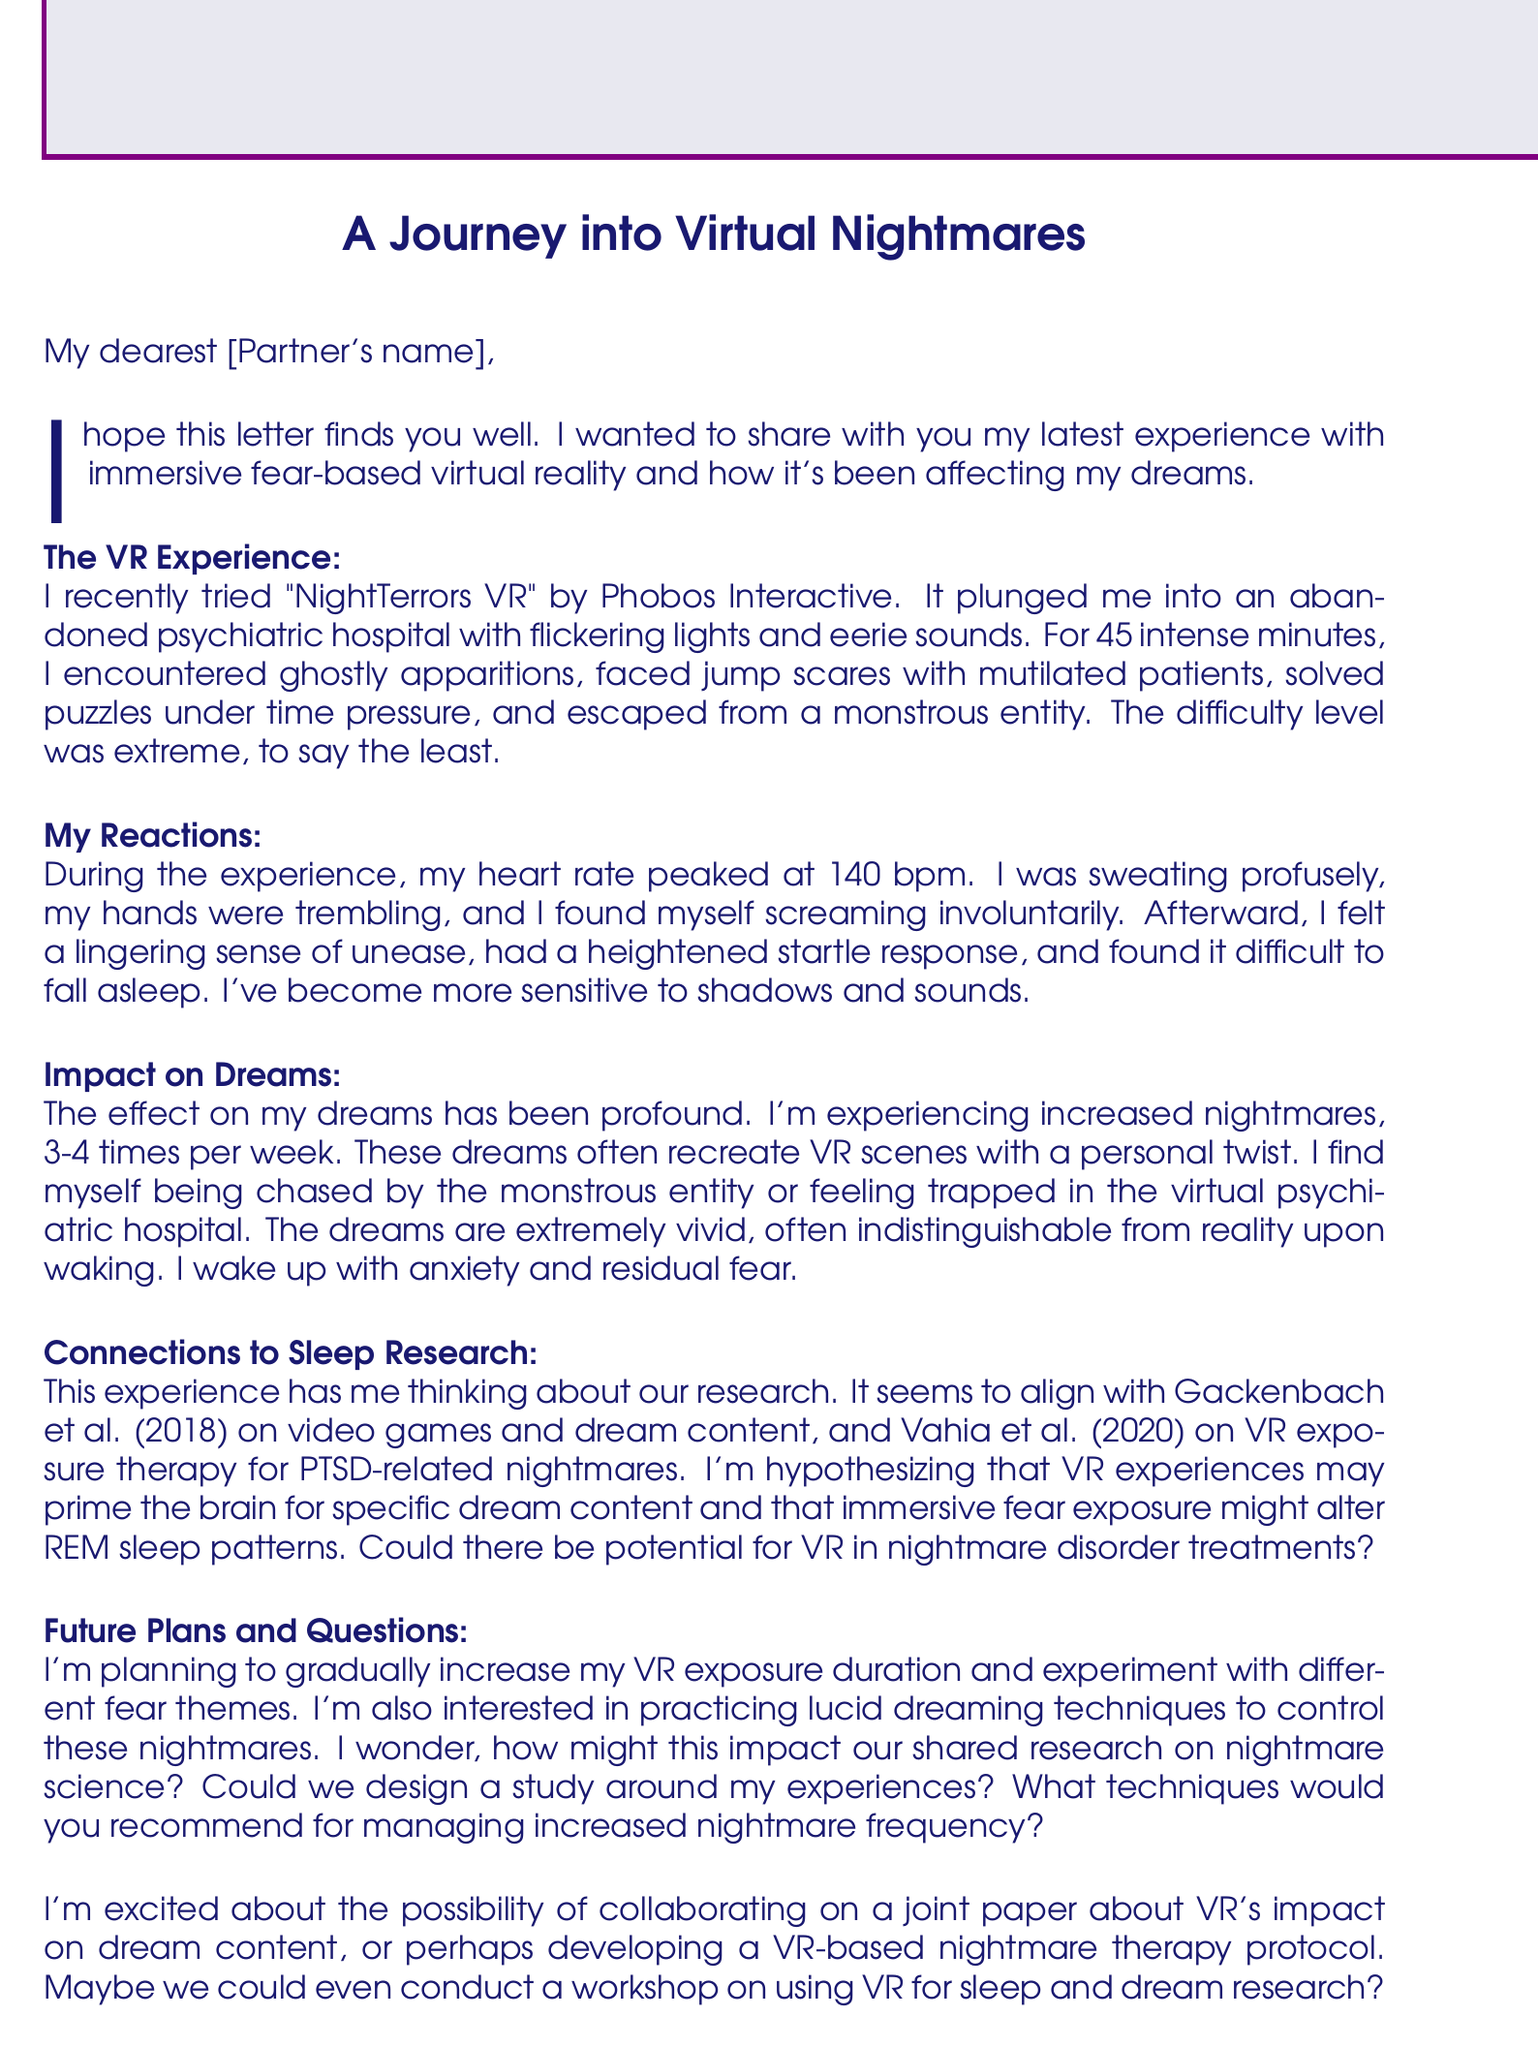What is the name of the VR application mentioned? The letter states that the VR application is called "NightTerrors VR."
Answer: NightTerrors VR Who is the developer of the VR application? The document specifies that the developer of the VR application is Phobos Interactive.
Answer: Phobos Interactive What emotions did the writer experience during the VR session? The document lists elevated heart rate, sweating, trembling hands, and involuntary screaming as emotional and physical reactions during the experience.
Answer: Elevated heart rate, profuse sweating, trembling hands, screaming involuntarily How many nightmares per week is the writer experiencing? The writer notes they are experiencing nightmares 3-4 times per week.
Answer: 3-4 times per week Which study is referenced regarding video games and dream content? The letter mentions Gackenbach et al. (2018) related to video games and dream content.
Answer: Gackenbach et al. (2018) What personal goal does the writer have regarding VR exposure? The writer plans to gradually increase their VR exposure duration as a personal goal.
Answer: Gradually increase VR exposure duration What emotional state does the writer report upon waking up? The document states that the writer wakes up with anxiety and residual fear from their dreams.
Answer: Anxiety and residual fear What research collaboration ideas are proposed by the writer? The writer suggests a joint paper on VR's impact on dream content and other collaborative projects.
Answer: Joint paper on VR's impact on dream content, development of a VR-based nightmare therapy protocol, workshop on using VR for sleep and dream research 